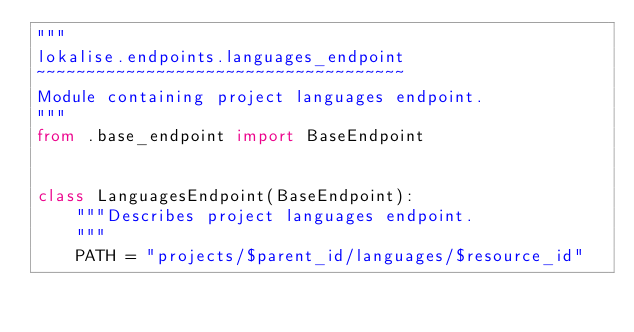Convert code to text. <code><loc_0><loc_0><loc_500><loc_500><_Python_>"""
lokalise.endpoints.languages_endpoint
~~~~~~~~~~~~~~~~~~~~~~~~~~~~~~~~~~~~~
Module containing project languages endpoint.
"""
from .base_endpoint import BaseEndpoint


class LanguagesEndpoint(BaseEndpoint):
    """Describes project languages endpoint.
    """
    PATH = "projects/$parent_id/languages/$resource_id"
</code> 